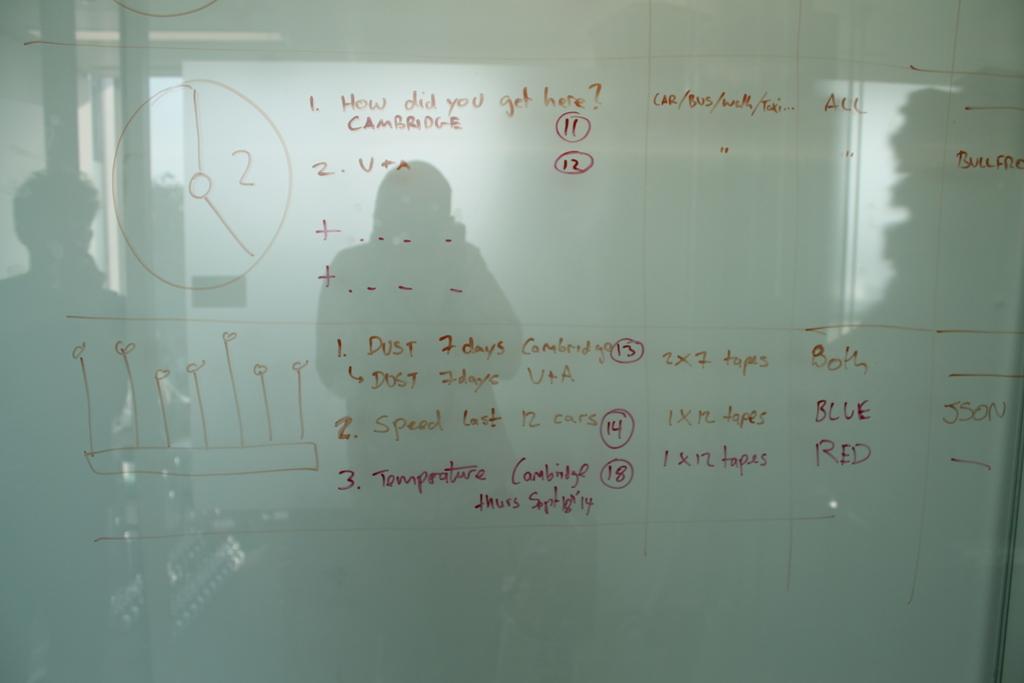What color is written on the white board?
Offer a terse response. Answering does not require reading text in the image. 